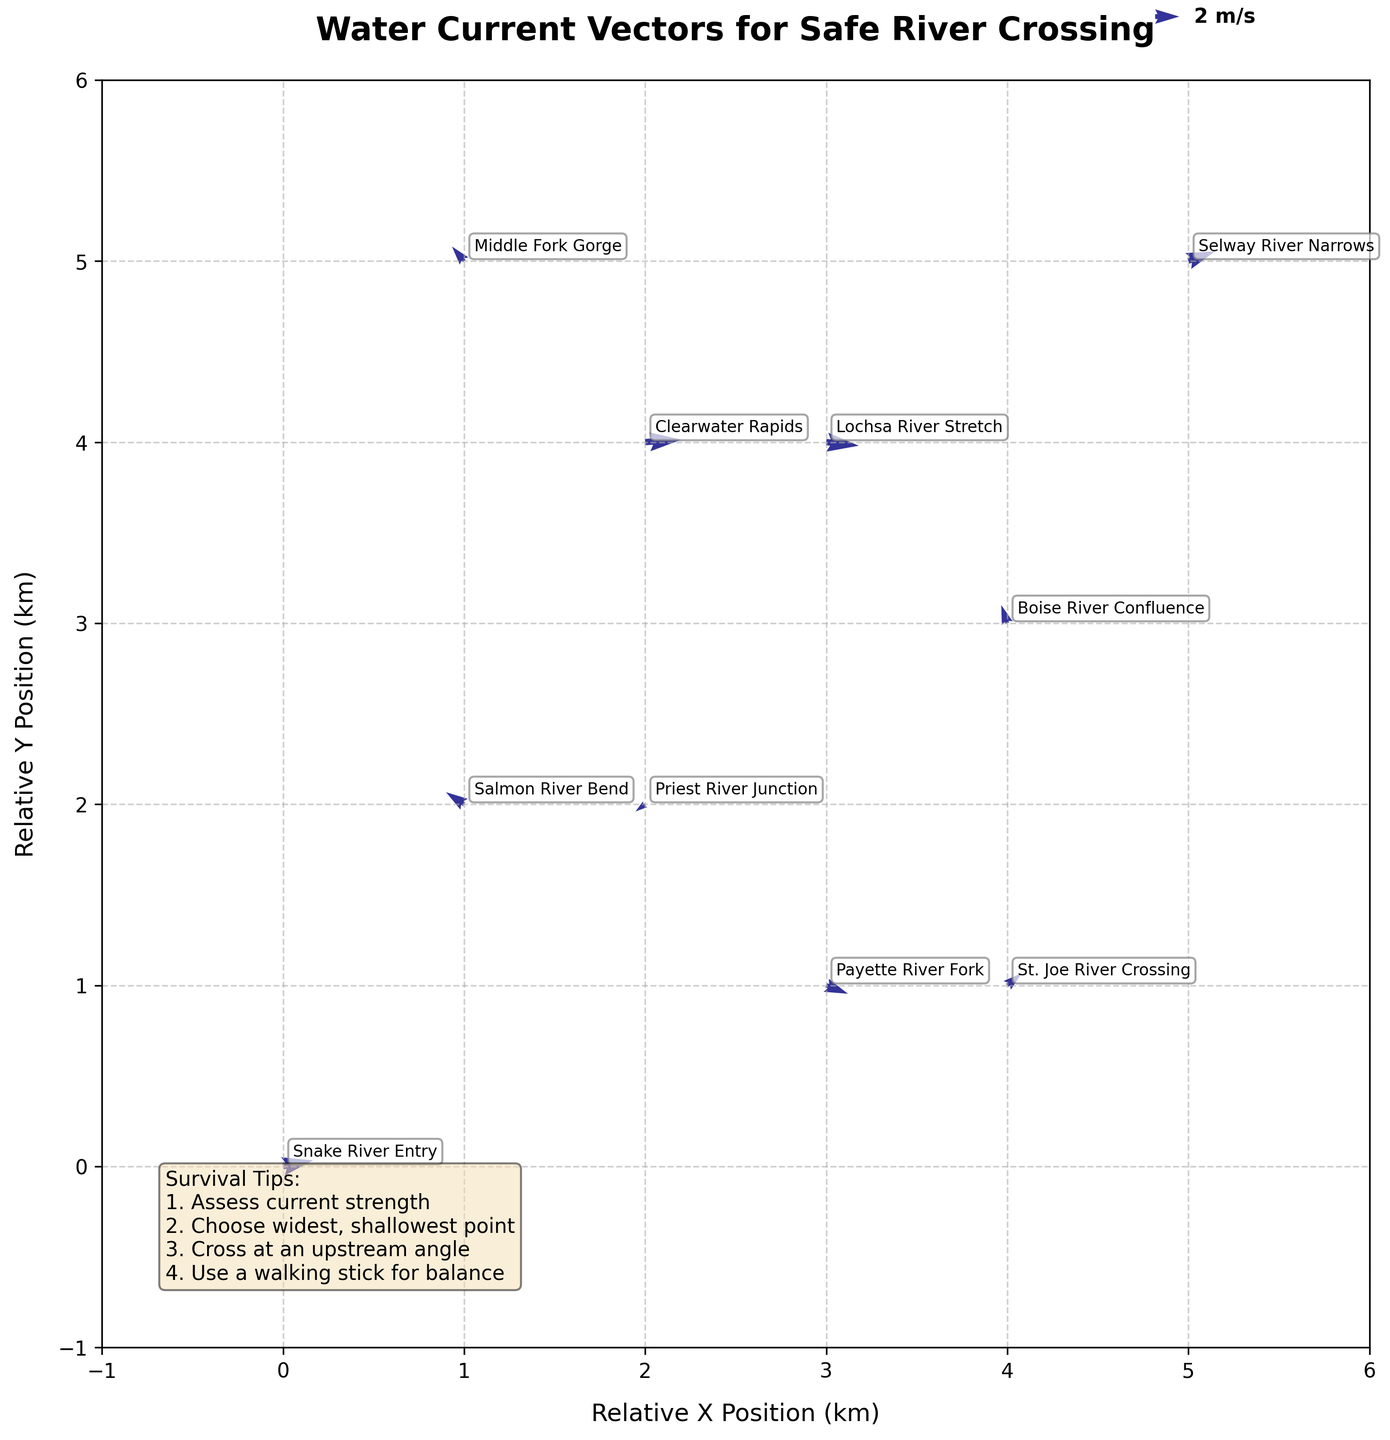What does the title of the figure indicate? The title of the figure is "Water Current Vectors for Safe River Crossing," which suggests that the figure shows water current vectors, likely to aid determining the safest spots to cross various rivers.
Answer: Water Current Vectors for Safe River Crossing What are the x and y axes labeled as? The x-axis is labeled as "Relative X Position (km)" and the y-axis is labeled as "Relative Y Position (km)." These labels indicate that the positions are relative distances in kilometers.
Answer: Relative X Position (km), Relative Y Position (km) How many locations are plotted on the figure? By counting the different data points with labels, there seem to be nine unique locations plotted on the figure.
Answer: Nine Which location shows the strongest current vector magnitude? To identify the strongest current vector magnitude, we compare the lengths of the vector arrows in the plot. The vector at "Clearwater Rapids" appears to be the longest, indicating the strongest current magnitude.
Answer: Clearwater Rapids What is the direction of the current at Boise River Confluence? The current direction at "Boise River Confluence" can be determined by looking at the arrow associated with it in the figure. The arrow points predominantly upward and slightly to the left.
Answer: Upward left Comparing Snake River Entry and Salmon River Bend, which has a stronger current? To compare the strengths, we look at the lengths of the vectors at both locations. The vector at "Snake River Entry" is longer than that at "Salmon River Bend," indicating a stronger current at Snake River Entry.
Answer: Snake River Entry At which location does the current vector point in a southwestern direction? A vector pointing in a southwestern direction would have components that are both negative in the X and Y directions. The location where the vector points in this direction is the "Priest River Junction."
Answer: Priest River Junction If you want the most minimal current vector for crossing, which location would be ideal? An ideal spot with a minimal current vector would have a very short arrow. The shortest arrow is found at "Salmon River Bend," indicating minimal current.
Answer: Salmon River Bend What is the average X-component of the vectors? To find the average X-component of the vectors, we need to sum the X-components of each vector and divide by the number of vectors. Sum of X-components (2.5 + -1.5 + 3 + 1.8 + -0.5 + 2.2 + -1 + 2.7 + 1.2 + -0.8) = 9.6, divided by 10 vectors is 9.6/10 = 0.96.
Answer: 0.96 Is there any location where the current vector has no component in the y direction? To determine if there are vectors with no Y-component, we look for vectors with a Y-component of zero. The location "Clearwater Rapids" has a current vector almost parallel to the X-axis, (3, 0.2), indicating nearly no Y-component.
Answer: Clearwater Rapids 